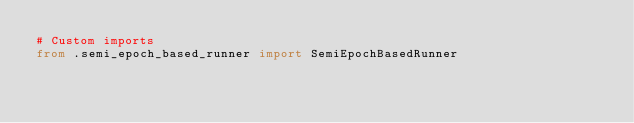Convert code to text. <code><loc_0><loc_0><loc_500><loc_500><_Python_># Custom imports
from .semi_epoch_based_runner import SemiEpochBasedRunner
</code> 